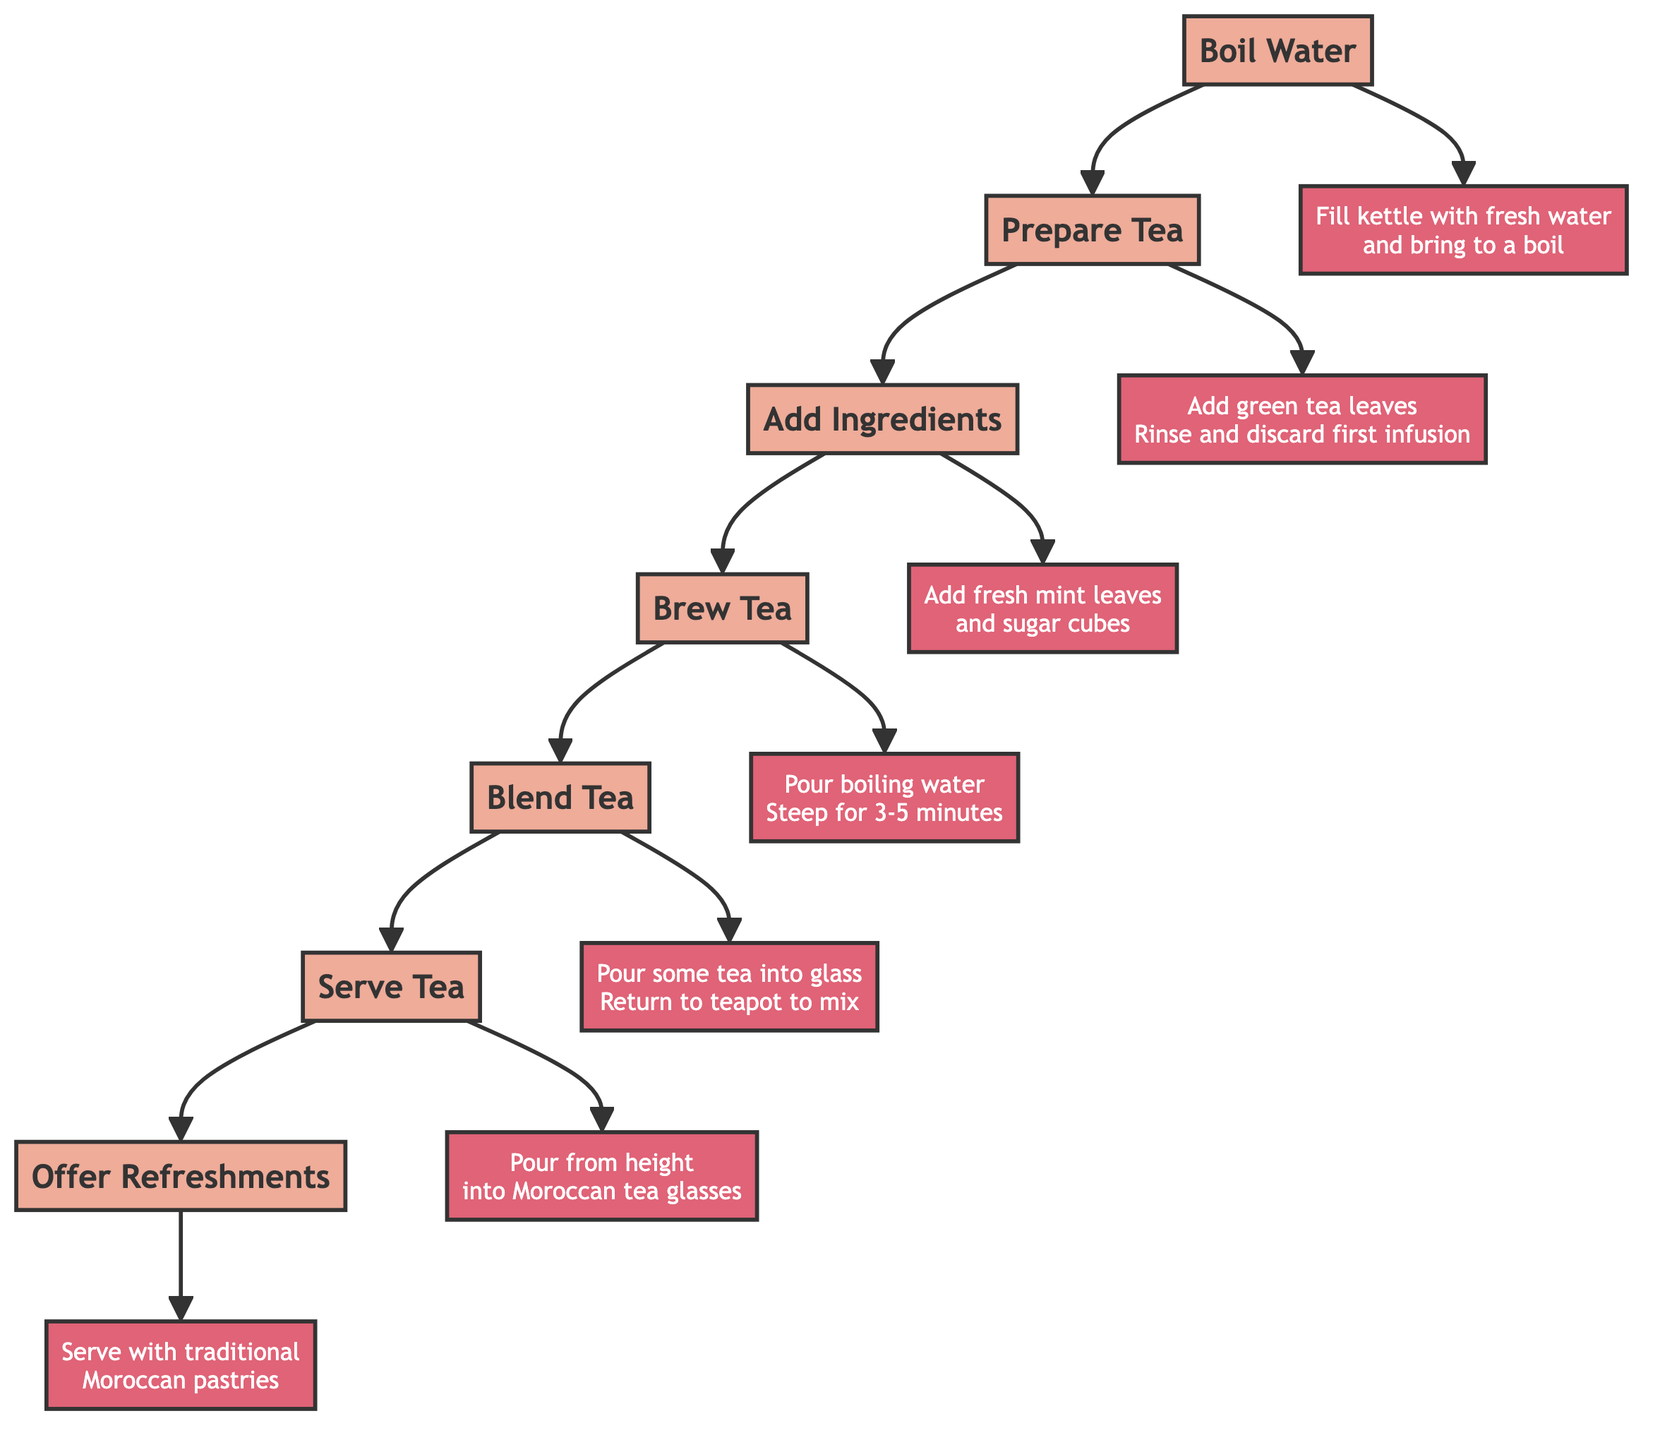What is the first step in the Moroccan tea ceremony? The first step, indicated in the flowchart, is to "Boil Water." It is the initial action that begins the tea preparation process.
Answer: Boil Water Which ingredient is added after preparing the tea? After the step "Prepare Tea," the next action is "Add Ingredients." In this step, fresh mint leaves and sugar cubes are added to the teapot.
Answer: Add Ingredients How many main steps are there in the Moroccan tea ceremony? By counting the main steps in the diagram, we find there are a total of 7 steps outlined in the preparation and serving sequence of the Moroccan tea ceremony.
Answer: 7 What is done with the tea after brewing? After the step "Brew Tea," the next action is "Blend Tea." During this step, some of the tea is poured into a glass and then returned to the teapot to mix the ingredients evenly.
Answer: Blend Tea What is the purpose of pouring the tea from a height? The action "Serve Tea" involves pouring the tea from a height into Moroccan tea glasses. The purpose of this action is to create froth on the surface of the tea, enhancing the presentation and experience.
Answer: Create froth What actions are directly related to tea preparation before serving? The steps directly related to tea preparation before serving include "Boil Water," "Prepare Tea," "Add Ingredients," "Brew Tea," and "Blend Tea." These steps collectively establish the foundation for serving the tea.
Answer: Boil Water, Prepare Tea, Add Ingredients, Brew Tea, Blend Tea In which step are refreshments offered? Refreshments are offered during the final step, "Offer Refreshments," where the tea is served along with traditional Moroccan pastries like almond briouats and chebakia.
Answer: Offer Refreshments What is the last action taken in the sequence? Following all preceding actions, the last action in the sequence is "Offer Refreshments," which concludes the Moroccan tea ceremony with the serving of pastries.
Answer: Offer Refreshments 